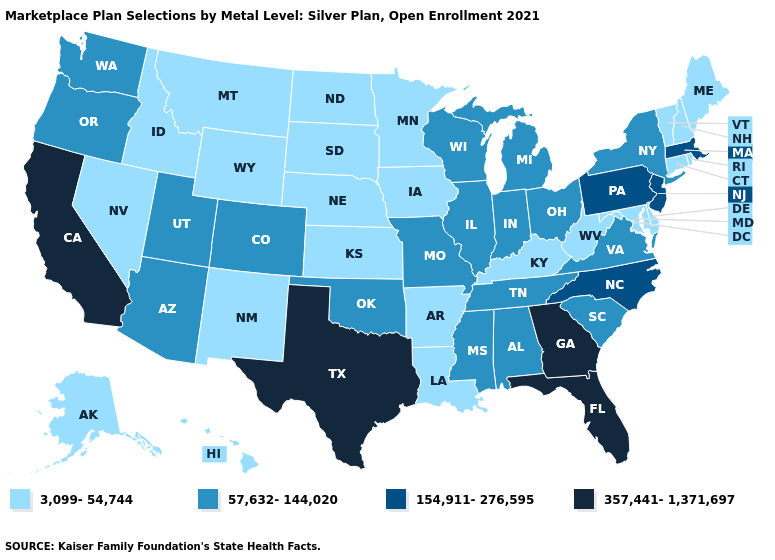Among the states that border Oregon , which have the highest value?
Keep it brief. California. What is the highest value in the USA?
Concise answer only. 357,441-1,371,697. Is the legend a continuous bar?
Short answer required. No. What is the highest value in states that border Maryland?
Be succinct. 154,911-276,595. Which states have the lowest value in the USA?
Be succinct. Alaska, Arkansas, Connecticut, Delaware, Hawaii, Idaho, Iowa, Kansas, Kentucky, Louisiana, Maine, Maryland, Minnesota, Montana, Nebraska, Nevada, New Hampshire, New Mexico, North Dakota, Rhode Island, South Dakota, Vermont, West Virginia, Wyoming. Does Connecticut have the same value as California?
Give a very brief answer. No. Among the states that border Virginia , which have the lowest value?
Keep it brief. Kentucky, Maryland, West Virginia. Does Maine have the lowest value in the USA?
Give a very brief answer. Yes. Name the states that have a value in the range 3,099-54,744?
Keep it brief. Alaska, Arkansas, Connecticut, Delaware, Hawaii, Idaho, Iowa, Kansas, Kentucky, Louisiana, Maine, Maryland, Minnesota, Montana, Nebraska, Nevada, New Hampshire, New Mexico, North Dakota, Rhode Island, South Dakota, Vermont, West Virginia, Wyoming. What is the value of North Dakota?
Answer briefly. 3,099-54,744. Which states have the lowest value in the USA?
Be succinct. Alaska, Arkansas, Connecticut, Delaware, Hawaii, Idaho, Iowa, Kansas, Kentucky, Louisiana, Maine, Maryland, Minnesota, Montana, Nebraska, Nevada, New Hampshire, New Mexico, North Dakota, Rhode Island, South Dakota, Vermont, West Virginia, Wyoming. What is the lowest value in states that border Louisiana?
Keep it brief. 3,099-54,744. What is the value of Washington?
Be succinct. 57,632-144,020. Among the states that border Texas , which have the highest value?
Be succinct. Oklahoma. Among the states that border West Virginia , which have the lowest value?
Give a very brief answer. Kentucky, Maryland. 